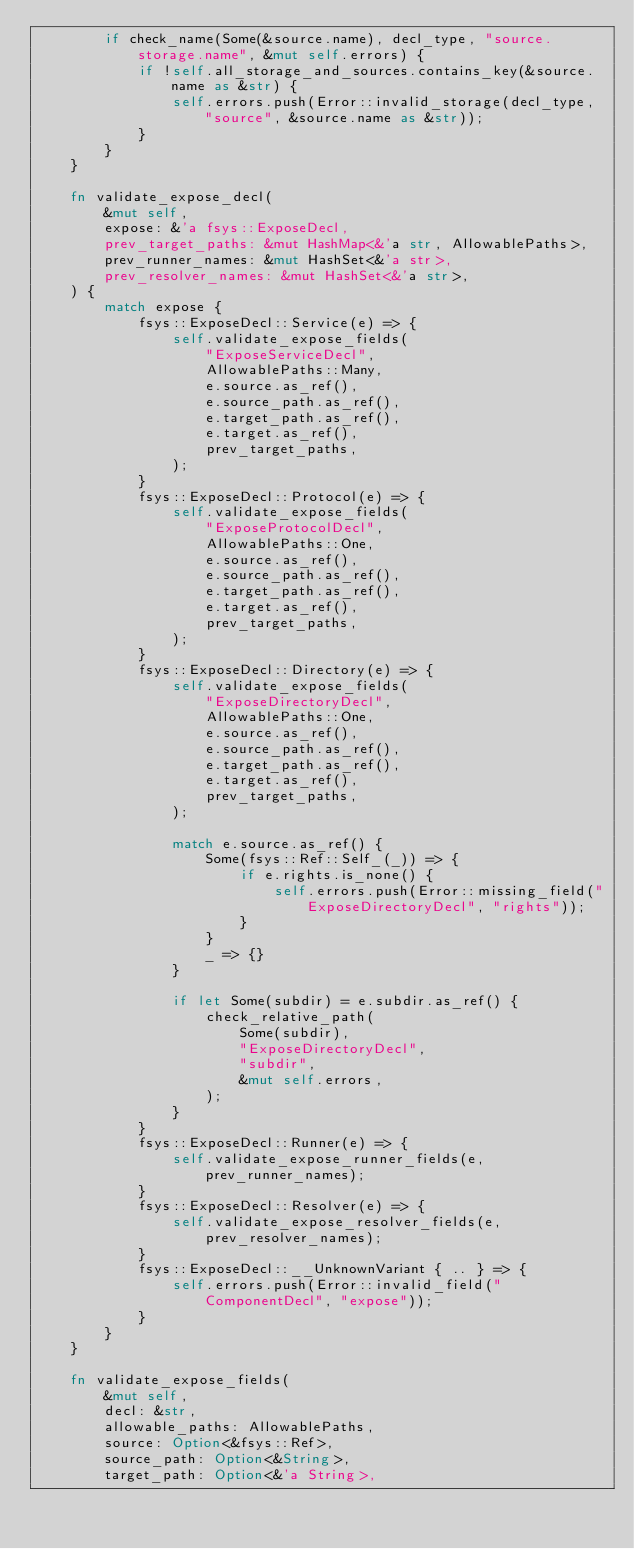<code> <loc_0><loc_0><loc_500><loc_500><_Rust_>        if check_name(Some(&source.name), decl_type, "source.storage.name", &mut self.errors) {
            if !self.all_storage_and_sources.contains_key(&source.name as &str) {
                self.errors.push(Error::invalid_storage(decl_type, "source", &source.name as &str));
            }
        }
    }

    fn validate_expose_decl(
        &mut self,
        expose: &'a fsys::ExposeDecl,
        prev_target_paths: &mut HashMap<&'a str, AllowablePaths>,
        prev_runner_names: &mut HashSet<&'a str>,
        prev_resolver_names: &mut HashSet<&'a str>,
    ) {
        match expose {
            fsys::ExposeDecl::Service(e) => {
                self.validate_expose_fields(
                    "ExposeServiceDecl",
                    AllowablePaths::Many,
                    e.source.as_ref(),
                    e.source_path.as_ref(),
                    e.target_path.as_ref(),
                    e.target.as_ref(),
                    prev_target_paths,
                );
            }
            fsys::ExposeDecl::Protocol(e) => {
                self.validate_expose_fields(
                    "ExposeProtocolDecl",
                    AllowablePaths::One,
                    e.source.as_ref(),
                    e.source_path.as_ref(),
                    e.target_path.as_ref(),
                    e.target.as_ref(),
                    prev_target_paths,
                );
            }
            fsys::ExposeDecl::Directory(e) => {
                self.validate_expose_fields(
                    "ExposeDirectoryDecl",
                    AllowablePaths::One,
                    e.source.as_ref(),
                    e.source_path.as_ref(),
                    e.target_path.as_ref(),
                    e.target.as_ref(),
                    prev_target_paths,
                );

                match e.source.as_ref() {
                    Some(fsys::Ref::Self_(_)) => {
                        if e.rights.is_none() {
                            self.errors.push(Error::missing_field("ExposeDirectoryDecl", "rights"));
                        }
                    }
                    _ => {}
                }

                if let Some(subdir) = e.subdir.as_ref() {
                    check_relative_path(
                        Some(subdir),
                        "ExposeDirectoryDecl",
                        "subdir",
                        &mut self.errors,
                    );
                }
            }
            fsys::ExposeDecl::Runner(e) => {
                self.validate_expose_runner_fields(e, prev_runner_names);
            }
            fsys::ExposeDecl::Resolver(e) => {
                self.validate_expose_resolver_fields(e, prev_resolver_names);
            }
            fsys::ExposeDecl::__UnknownVariant { .. } => {
                self.errors.push(Error::invalid_field("ComponentDecl", "expose"));
            }
        }
    }

    fn validate_expose_fields(
        &mut self,
        decl: &str,
        allowable_paths: AllowablePaths,
        source: Option<&fsys::Ref>,
        source_path: Option<&String>,
        target_path: Option<&'a String>,</code> 